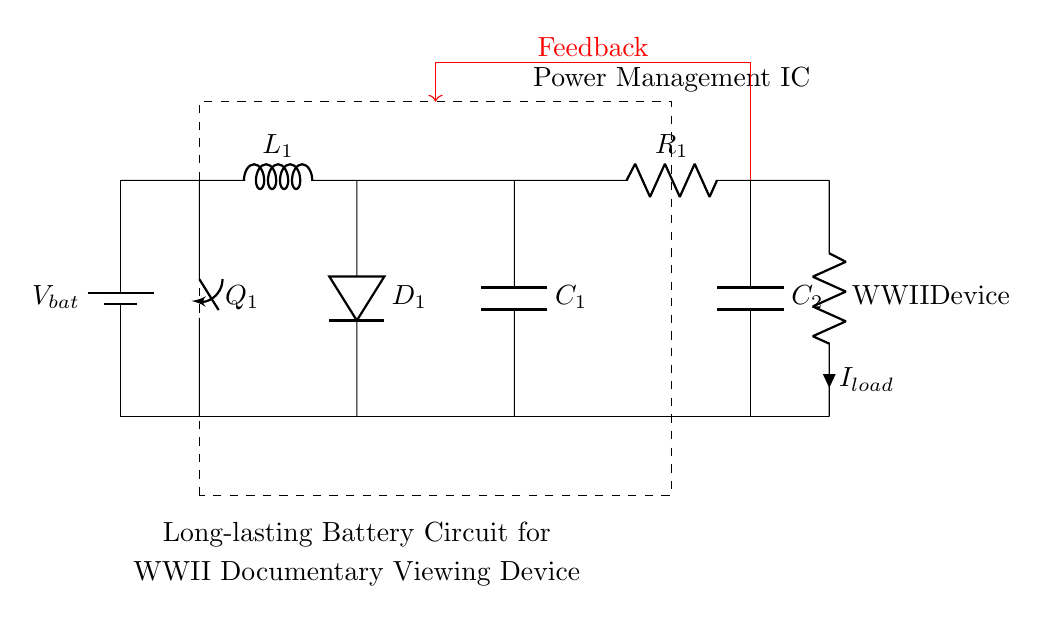What is the main purpose of the Power Management IC? The Power Management IC is responsible for regulating and managing the power supply to prolong the battery life of the device. It controls the buck converter and linear regulator to optimize efficiency.
Answer: Regulating power supply What type of device is connected as the load in this circuit? The load in this circuit is labeled as "WWII Device," indicating that this is the main component that consumes power from the circuit.
Answer: WWII Device How many capacitors are present in this circuit? There are two capacitors in the circuit: C1 and C2. They are used to smooth the voltage and stabilize the power supply.
Answer: Two What component is used for feedback in the circuit? The feedback in this circuit is indicated by the red line leading from C2 back to the control loop, helping to adjust the output voltage based on the load's requirements.
Answer: Feedback loop What is the role of the inductor labeled L1? The inductor L1 is part of the buck converter, storing energy when the switch Q1 is closed and releasing it to power the load when the switch is open, thereby regulating voltage and current.
Answer: Energy storage What type of regulator follows the buck converter in this circuit? Following the buck converter, there is an LDO (Low Drop-Out) regulator, which provides a stable output voltage even when the input voltage is close to the output voltage.
Answer: LDO Regulator 